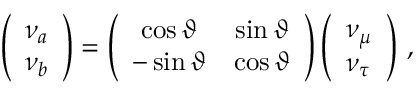<formula> <loc_0><loc_0><loc_500><loc_500>\left ( \begin{array} { l } { { \nu _ { a } } } \\ { { \nu _ { b } } } \end{array} \right ) = \left ( \begin{array} { c c } { { \cos { \vartheta } } } & { { \sin { \vartheta } } } \\ { { - \sin { \vartheta } } } & { { \cos { \vartheta } } } \end{array} \right ) \left ( \begin{array} { l } { { \nu _ { \mu } } } \\ { { \nu _ { \tau } } } \end{array} \right ) \, ,</formula> 